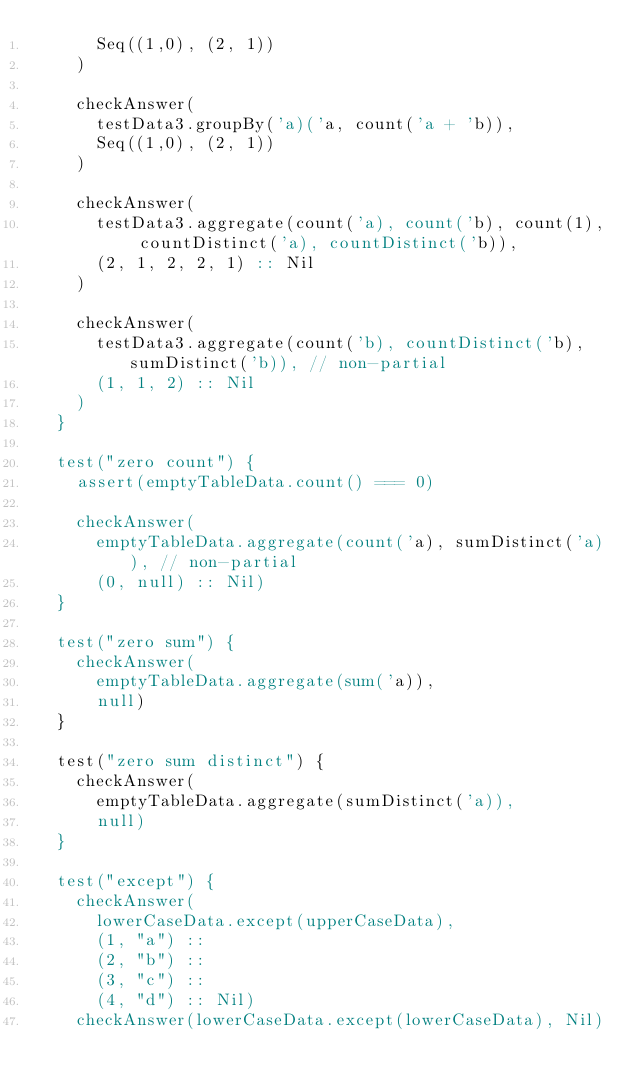<code> <loc_0><loc_0><loc_500><loc_500><_Scala_>      Seq((1,0), (2, 1))
    )

    checkAnswer(
      testData3.groupBy('a)('a, count('a + 'b)),
      Seq((1,0), (2, 1))
    )

    checkAnswer(
      testData3.aggregate(count('a), count('b), count(1), countDistinct('a), countDistinct('b)),
      (2, 1, 2, 2, 1) :: Nil
    )

    checkAnswer(
      testData3.aggregate(count('b), countDistinct('b), sumDistinct('b)), // non-partial
      (1, 1, 2) :: Nil
    )
  }

  test("zero count") {
    assert(emptyTableData.count() === 0)

    checkAnswer(
      emptyTableData.aggregate(count('a), sumDistinct('a)), // non-partial
      (0, null) :: Nil)
  }

  test("zero sum") {
    checkAnswer(
      emptyTableData.aggregate(sum('a)),
      null)
  }

  test("zero sum distinct") {
    checkAnswer(
      emptyTableData.aggregate(sumDistinct('a)),
      null)
  }

  test("except") {
    checkAnswer(
      lowerCaseData.except(upperCaseData),
      (1, "a") ::
      (2, "b") ::
      (3, "c") ::
      (4, "d") :: Nil)
    checkAnswer(lowerCaseData.except(lowerCaseData), Nil)</code> 